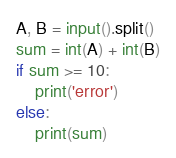<code> <loc_0><loc_0><loc_500><loc_500><_Python_>A, B = input().split()
sum = int(A) + int(B)
if sum >= 10:
    print('error')
else:
    print(sum)
</code> 